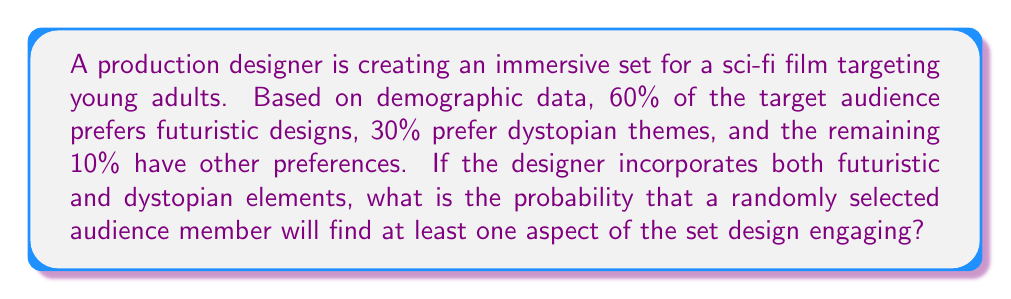What is the answer to this math problem? Let's approach this step-by-step:

1) Define events:
   F: Audience member prefers futuristic designs
   D: Audience member prefers dystopian themes

2) Given probabilities:
   $P(F) = 0.60$
   $P(D) = 0.30$

3) We need to find the probability of the audience member liking at least one aspect, which is the same as 1 minus the probability of liking neither aspect.

4) The probability of not liking either aspect is the complement of both F and D:
   $P(\text{neither}) = 1 - P(F \text{ or } D)$

5) To find $P(F \text{ or } D)$, we use the addition rule of probability:
   $P(F \text{ or } D) = P(F) + P(D) - P(F \text{ and } D)$

6) We don't know $P(F \text{ and } D)$, but we can assume independence between futuristic and dystopian preferences. So:
   $P(F \text{ and } D) = P(F) \times P(D) = 0.60 \times 0.30 = 0.18$

7) Now we can calculate:
   $P(F \text{ or } D) = 0.60 + 0.30 - 0.18 = 0.72$

8) Therefore, the probability of liking at least one aspect is:
   $P(\text{at least one}) = 1 - P(\text{neither}) = 1 - (1 - 0.72) = 0.72$
Answer: 0.72 